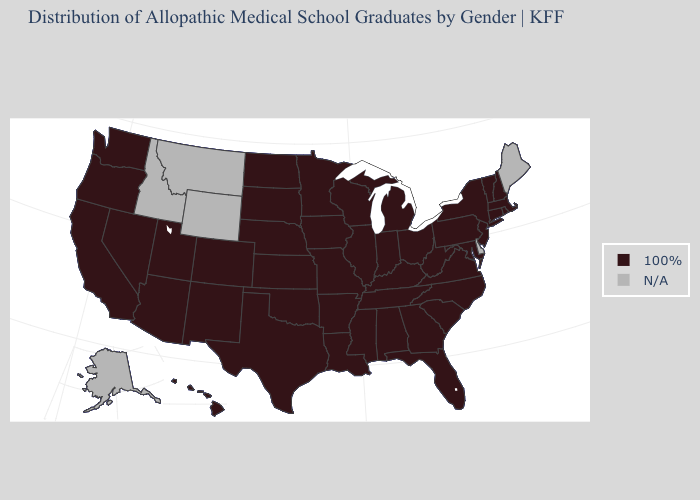Name the states that have a value in the range 100%?
Answer briefly. Alabama, Arizona, Arkansas, California, Colorado, Connecticut, Florida, Georgia, Hawaii, Illinois, Indiana, Iowa, Kansas, Kentucky, Louisiana, Maryland, Massachusetts, Michigan, Minnesota, Mississippi, Missouri, Nebraska, Nevada, New Hampshire, New Jersey, New Mexico, New York, North Carolina, North Dakota, Ohio, Oklahoma, Oregon, Pennsylvania, Rhode Island, South Carolina, South Dakota, Tennessee, Texas, Utah, Vermont, Virginia, Washington, West Virginia, Wisconsin. Name the states that have a value in the range 100%?
Answer briefly. Alabama, Arizona, Arkansas, California, Colorado, Connecticut, Florida, Georgia, Hawaii, Illinois, Indiana, Iowa, Kansas, Kentucky, Louisiana, Maryland, Massachusetts, Michigan, Minnesota, Mississippi, Missouri, Nebraska, Nevada, New Hampshire, New Jersey, New Mexico, New York, North Carolina, North Dakota, Ohio, Oklahoma, Oregon, Pennsylvania, Rhode Island, South Carolina, South Dakota, Tennessee, Texas, Utah, Vermont, Virginia, Washington, West Virginia, Wisconsin. Does the first symbol in the legend represent the smallest category?
Keep it brief. No. Which states have the lowest value in the South?
Answer briefly. Alabama, Arkansas, Florida, Georgia, Kentucky, Louisiana, Maryland, Mississippi, North Carolina, Oklahoma, South Carolina, Tennessee, Texas, Virginia, West Virginia. What is the value of Texas?
Concise answer only. 100%. Among the states that border Georgia , which have the lowest value?
Answer briefly. Alabama, Florida, North Carolina, South Carolina, Tennessee. What is the value of Iowa?
Quick response, please. 100%. Which states have the highest value in the USA?
Answer briefly. Alabama, Arizona, Arkansas, California, Colorado, Connecticut, Florida, Georgia, Hawaii, Illinois, Indiana, Iowa, Kansas, Kentucky, Louisiana, Maryland, Massachusetts, Michigan, Minnesota, Mississippi, Missouri, Nebraska, Nevada, New Hampshire, New Jersey, New Mexico, New York, North Carolina, North Dakota, Ohio, Oklahoma, Oregon, Pennsylvania, Rhode Island, South Carolina, South Dakota, Tennessee, Texas, Utah, Vermont, Virginia, Washington, West Virginia, Wisconsin. Among the states that border Iowa , which have the lowest value?
Quick response, please. Illinois, Minnesota, Missouri, Nebraska, South Dakota, Wisconsin. Among the states that border Massachusetts , which have the highest value?
Give a very brief answer. Connecticut, New Hampshire, New York, Rhode Island, Vermont. Among the states that border Oklahoma , which have the highest value?
Short answer required. Arkansas, Colorado, Kansas, Missouri, New Mexico, Texas. What is the value of Rhode Island?
Short answer required. 100%. 